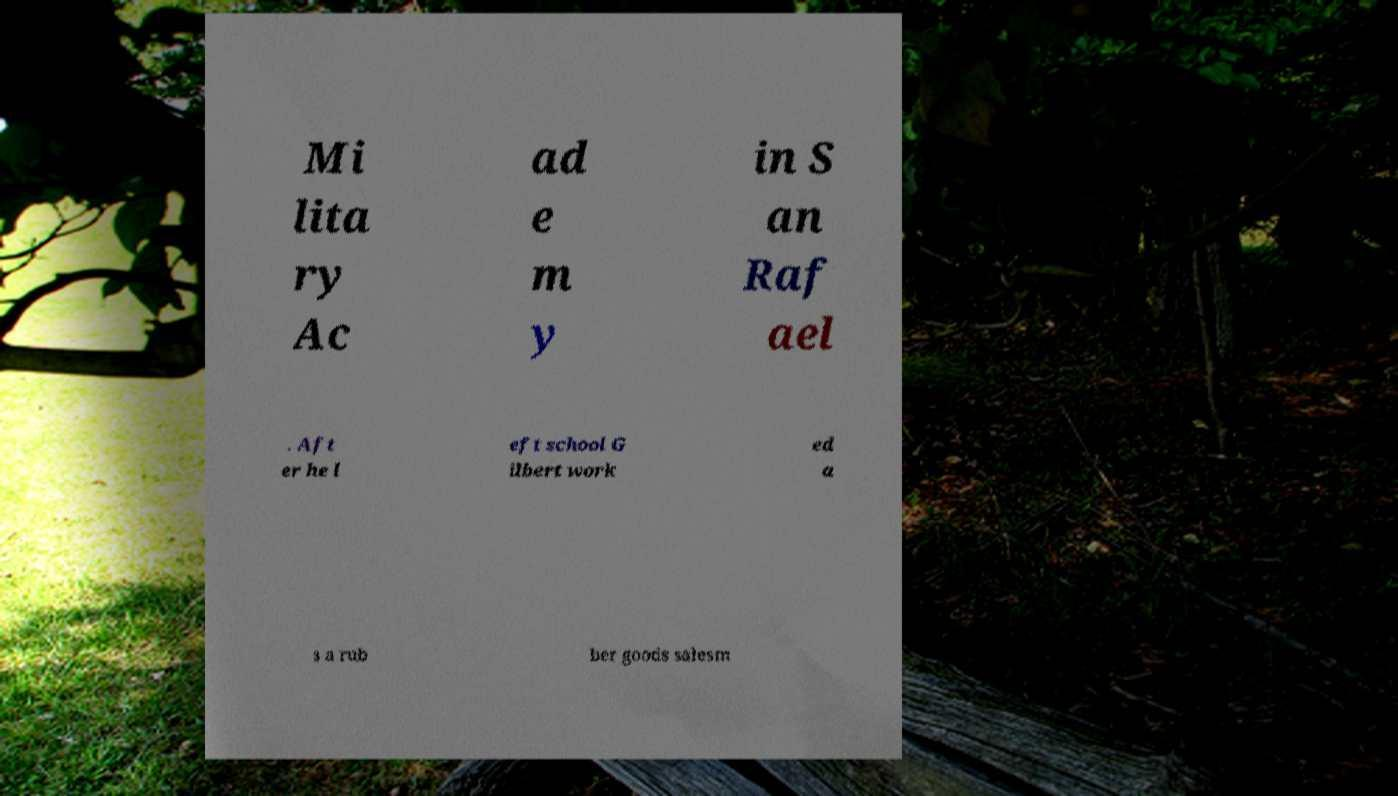Could you assist in decoding the text presented in this image and type it out clearly? Mi lita ry Ac ad e m y in S an Raf ael . Aft er he l eft school G ilbert work ed a s a rub ber goods salesm 